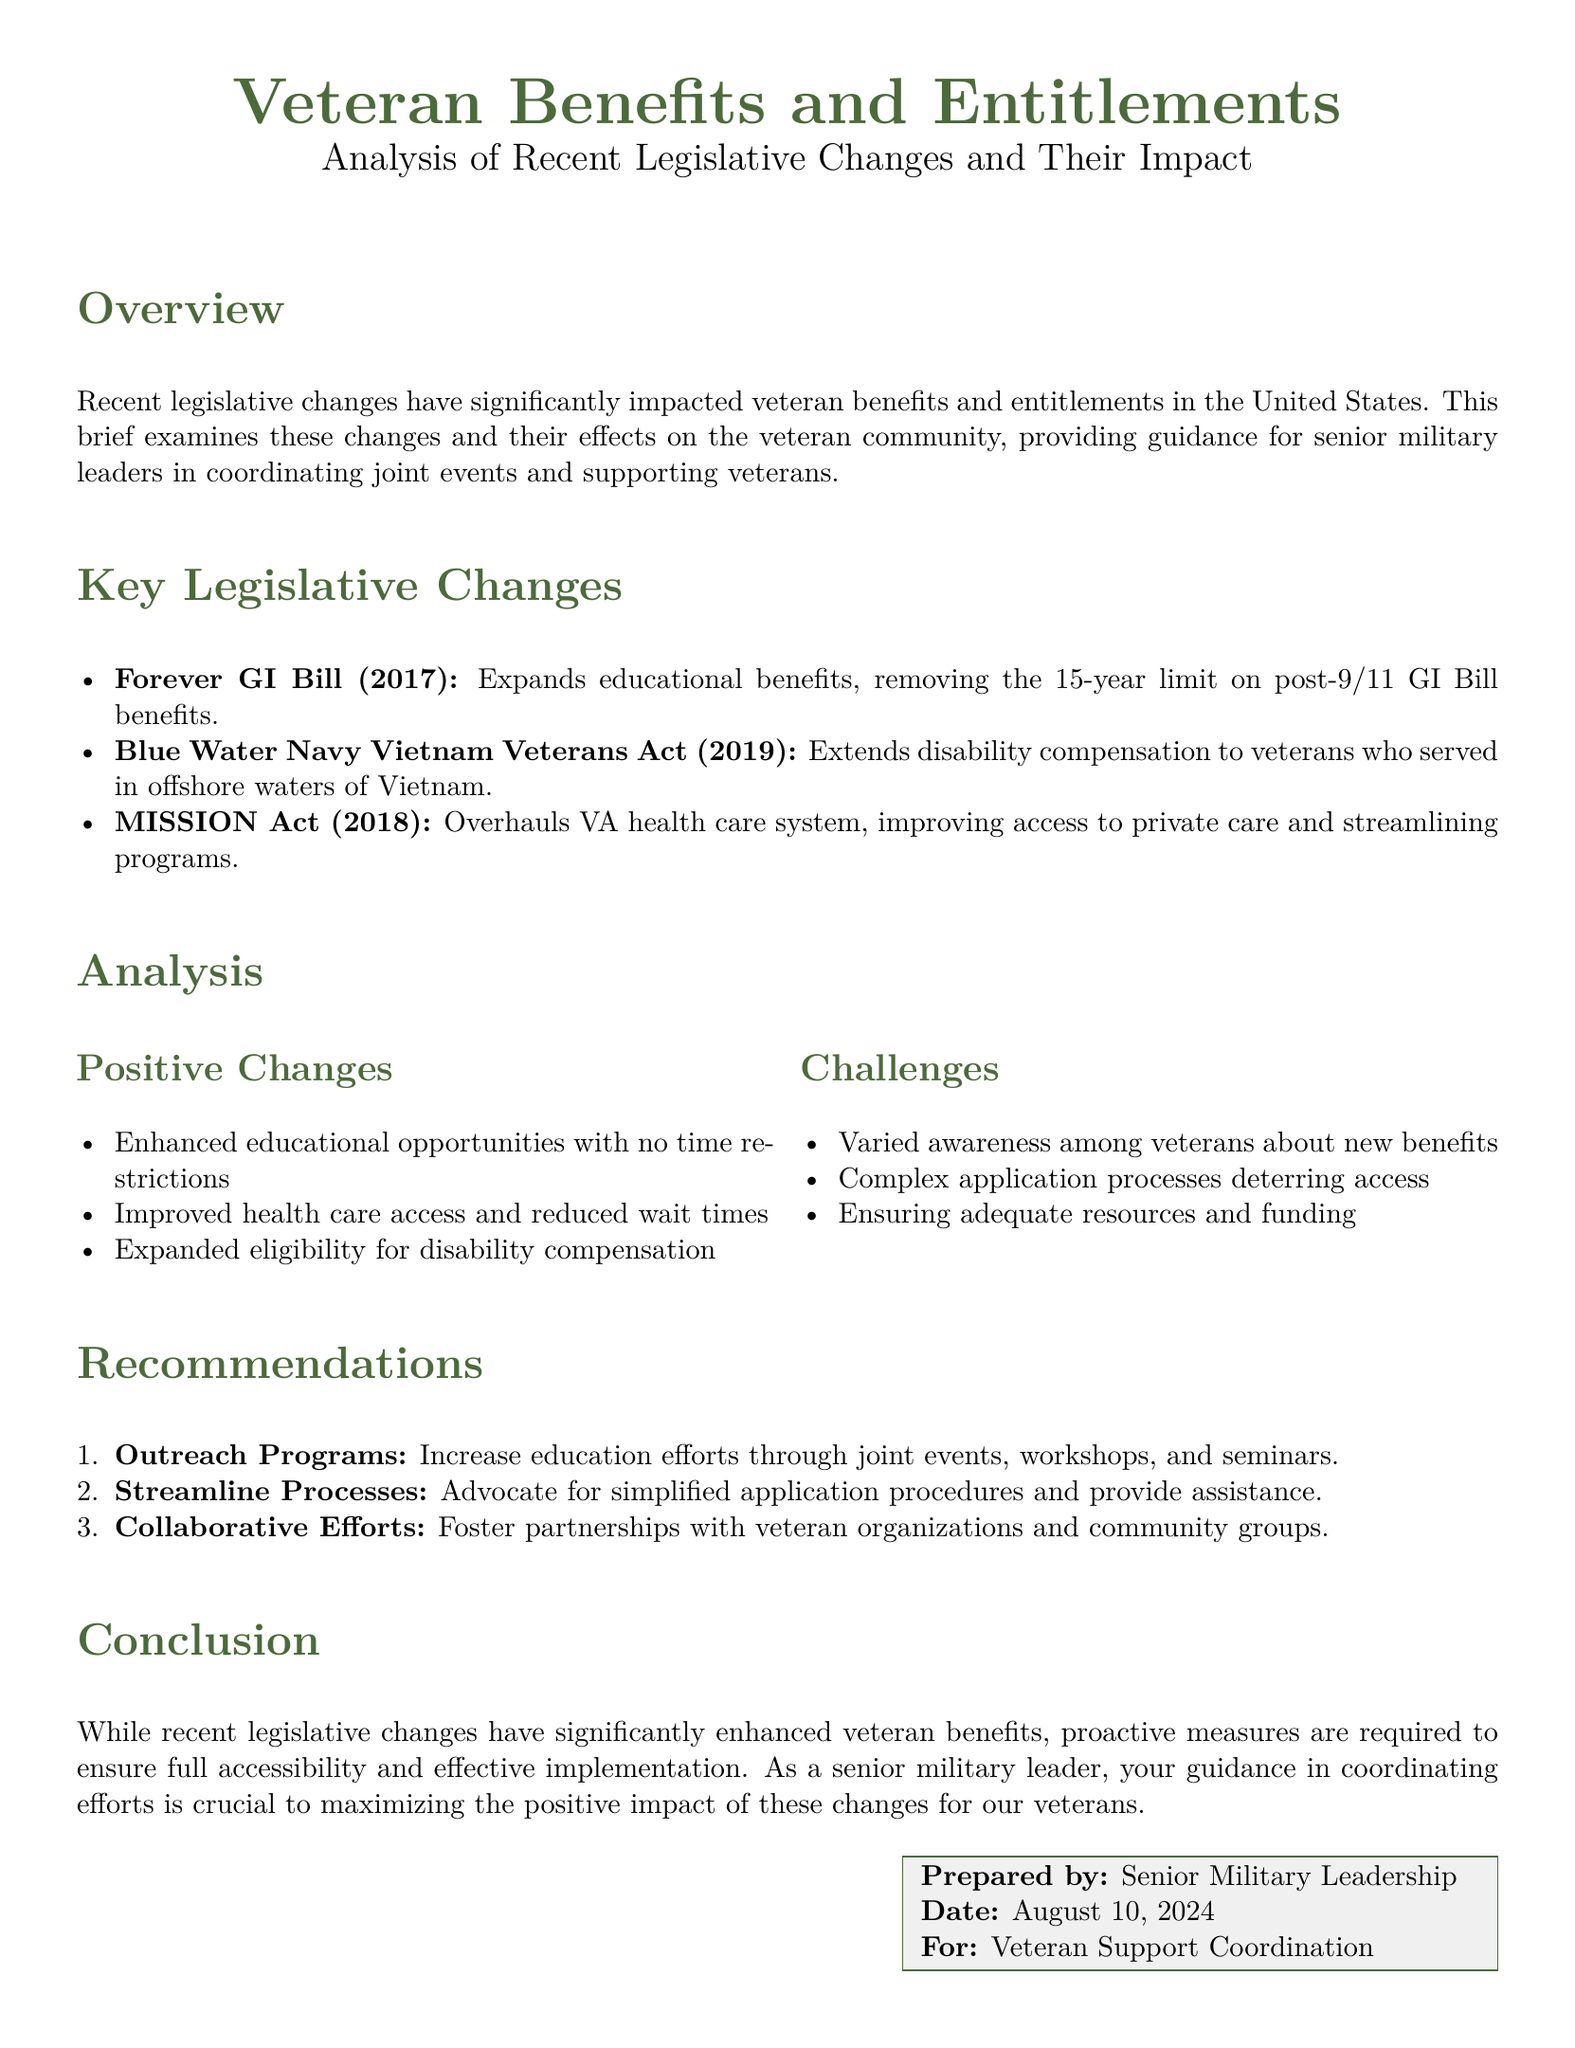What is the title of the document? The title of the document is presented at the top, stating its purpose and content.
Answer: Veteran Benefits and Entitlements What year was the Forever GI Bill enacted? The specific legislative change mentioned with its enactment year provides a clear reference to the timeline of veteran benefits.
Answer: 2017 What is one of the positive changes from recent legislation? The document lists several positive aspects under the analysis section, highlighting the impacts of legislative changes.
Answer: Enhanced educational opportunities with no time restrictions What major act overhauled the VA health care system? The document names this specific act that aims to improve access and services for veterans, showing significant legislative shifts.
Answer: MISSION Act What challenge is mentioned regarding veterans’ awareness? The challenges section outlines issues that veterans face, including understanding their new benefits.
Answer: Varied awareness among veterans about new benefits What recommendation focuses on increasing education efforts? The recommendations section proposes actions to improve veteran outreach, essential for implementing legislative changes.
Answer: Outreach Programs How many legislative changes are summarized in the document? The overview section presents a concise overview of the legislative changes discussed.
Answer: Three What legislation extends disability compensation to veterans serving in offshore waters of Vietnam? The specific act outlined in the document addresses this historical context and its impact on veterans.
Answer: Blue Water Navy Vietnam Veterans Act 